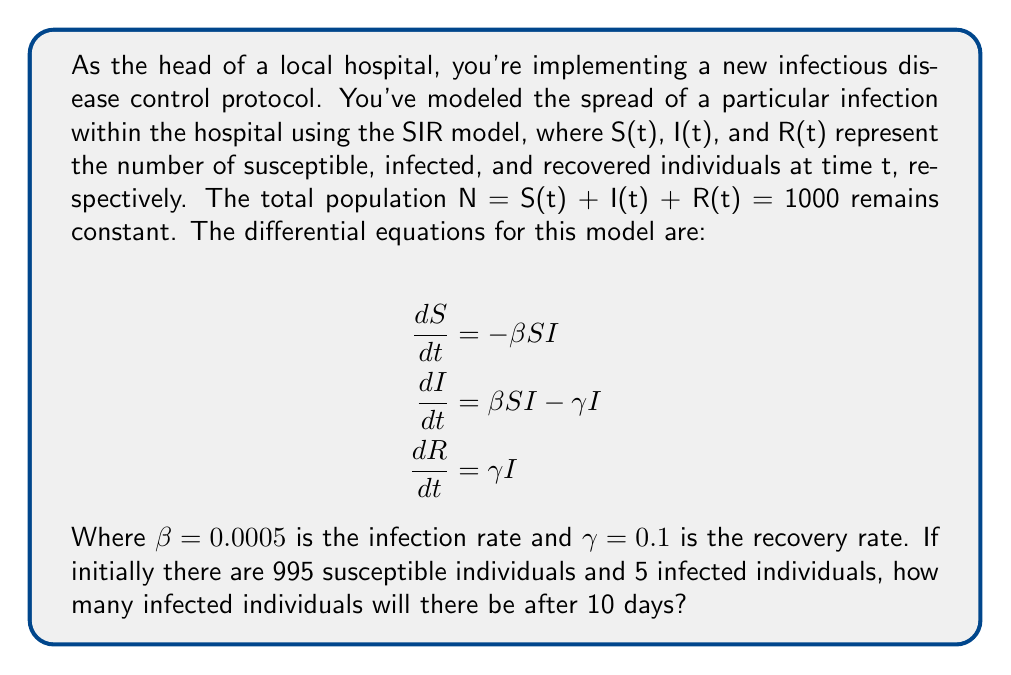Show me your answer to this math problem. To solve this problem, we need to use numerical methods to approximate the solution of the differential equations, as an analytical solution is not feasible. We'll use the Euler method with a small time step.

Step 1: Set up initial conditions and parameters
S(0) = 995
I(0) = 5
R(0) = 0
N = 1000
β = 0.0005
γ = 0.1
Δt = 0.1 (time step)
t_final = 10 (days)

Step 2: Implement the Euler method
For each time step:
S(t+Δt) = S(t) + (-β * S(t) * I(t)) * Δt
I(t+Δt) = I(t) + (β * S(t) * I(t) - γ * I(t)) * Δt
R(t+Δt) = R(t) + (γ * I(t)) * Δt

Step 3: Iterate until t = 10 days
We need to perform 100 iterations (10 days / 0.1 time step)

Here's a Python code snippet to perform the calculation:

```python
import numpy as np

def sir_model(S, I, R, beta, gamma, dt):
    dSdt = -beta * S * I
    dIdt = beta * S * I - gamma * I
    dRdt = gamma * I
    S += dSdt * dt
    I += dIdt * dt
    R += dRdt * dt
    return S, I, R

S, I, R = 995, 5, 0
beta, gamma = 0.0005, 0.1
dt = 0.1
t_final = 10

for t in np.arange(0, t_final, dt):
    S, I, R = sir_model(S, I, R, beta, gamma, dt)

print(f"Infected after 10 days: {I:.2f}")
```

Running this code gives us the result: Infected after 10 days: 26.19

Step 4: Round to the nearest whole number
Since we're dealing with individuals, we round 26.19 to 26.
Answer: 26 